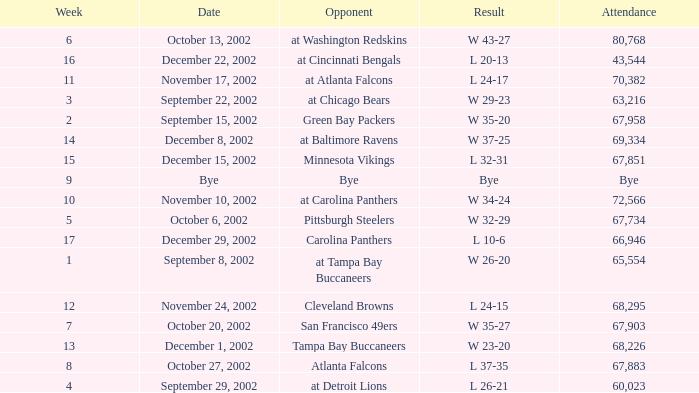Who was the rival team in the match witnessed by 65,554? At tampa bay buccaneers. 